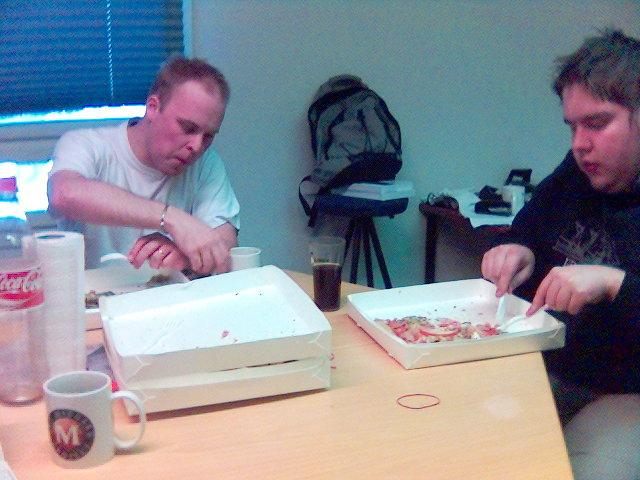What type of beverages are being consumed by the pizza eater? Please explain your reasoning. soft drinks. There is a a couple men sitting at a table eating pizza. there is an empty bottle of coca cola on the table. 